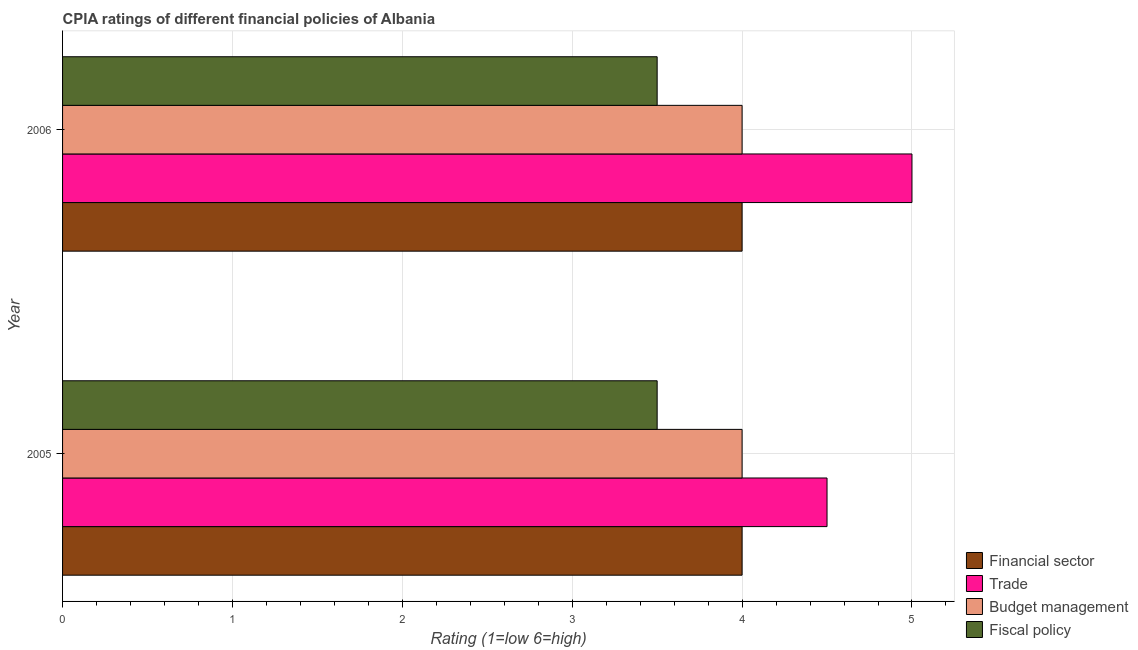How many bars are there on the 2nd tick from the top?
Your response must be concise. 4. Across all years, what is the maximum cpia rating of financial sector?
Ensure brevity in your answer.  4. Across all years, what is the minimum cpia rating of financial sector?
Offer a terse response. 4. What is the total cpia rating of financial sector in the graph?
Provide a short and direct response. 8. What is the average cpia rating of trade per year?
Your response must be concise. 4.75. In how many years, is the cpia rating of fiscal policy greater than 4 ?
Give a very brief answer. 0. What is the ratio of the cpia rating of financial sector in 2005 to that in 2006?
Give a very brief answer. 1. Is the cpia rating of fiscal policy in 2005 less than that in 2006?
Your response must be concise. No. In how many years, is the cpia rating of budget management greater than the average cpia rating of budget management taken over all years?
Make the answer very short. 0. What does the 3rd bar from the top in 2005 represents?
Provide a short and direct response. Trade. What does the 2nd bar from the bottom in 2006 represents?
Provide a succinct answer. Trade. Is it the case that in every year, the sum of the cpia rating of financial sector and cpia rating of trade is greater than the cpia rating of budget management?
Provide a short and direct response. Yes. How many bars are there?
Give a very brief answer. 8. Are the values on the major ticks of X-axis written in scientific E-notation?
Offer a terse response. No. How many legend labels are there?
Your response must be concise. 4. What is the title of the graph?
Ensure brevity in your answer.  CPIA ratings of different financial policies of Albania. Does "Permanent crop land" appear as one of the legend labels in the graph?
Ensure brevity in your answer.  No. What is the label or title of the Y-axis?
Give a very brief answer. Year. What is the Rating (1=low 6=high) of Budget management in 2005?
Offer a very short reply. 4. What is the Rating (1=low 6=high) of Fiscal policy in 2005?
Keep it short and to the point. 3.5. What is the Rating (1=low 6=high) of Budget management in 2006?
Give a very brief answer. 4. What is the Rating (1=low 6=high) of Fiscal policy in 2006?
Provide a short and direct response. 3.5. Across all years, what is the minimum Rating (1=low 6=high) of Financial sector?
Provide a succinct answer. 4. Across all years, what is the minimum Rating (1=low 6=high) of Fiscal policy?
Provide a succinct answer. 3.5. What is the total Rating (1=low 6=high) of Financial sector in the graph?
Ensure brevity in your answer.  8. What is the total Rating (1=low 6=high) in Trade in the graph?
Give a very brief answer. 9.5. What is the total Rating (1=low 6=high) of Budget management in the graph?
Your response must be concise. 8. What is the difference between the Rating (1=low 6=high) in Budget management in 2005 and that in 2006?
Ensure brevity in your answer.  0. What is the difference between the Rating (1=low 6=high) of Financial sector in 2005 and the Rating (1=low 6=high) of Trade in 2006?
Your answer should be compact. -1. What is the difference between the Rating (1=low 6=high) of Financial sector in 2005 and the Rating (1=low 6=high) of Budget management in 2006?
Give a very brief answer. 0. What is the difference between the Rating (1=low 6=high) of Trade in 2005 and the Rating (1=low 6=high) of Budget management in 2006?
Ensure brevity in your answer.  0.5. What is the difference between the Rating (1=low 6=high) in Budget management in 2005 and the Rating (1=low 6=high) in Fiscal policy in 2006?
Your response must be concise. 0.5. What is the average Rating (1=low 6=high) of Trade per year?
Your answer should be very brief. 4.75. What is the average Rating (1=low 6=high) in Budget management per year?
Ensure brevity in your answer.  4. In the year 2005, what is the difference between the Rating (1=low 6=high) in Financial sector and Rating (1=low 6=high) in Trade?
Your answer should be very brief. -0.5. In the year 2005, what is the difference between the Rating (1=low 6=high) in Financial sector and Rating (1=low 6=high) in Budget management?
Give a very brief answer. 0. In the year 2005, what is the difference between the Rating (1=low 6=high) in Financial sector and Rating (1=low 6=high) in Fiscal policy?
Your answer should be compact. 0.5. In the year 2005, what is the difference between the Rating (1=low 6=high) in Trade and Rating (1=low 6=high) in Budget management?
Give a very brief answer. 0.5. In the year 2006, what is the difference between the Rating (1=low 6=high) in Financial sector and Rating (1=low 6=high) in Fiscal policy?
Ensure brevity in your answer.  0.5. In the year 2006, what is the difference between the Rating (1=low 6=high) in Trade and Rating (1=low 6=high) in Budget management?
Make the answer very short. 1. In the year 2006, what is the difference between the Rating (1=low 6=high) in Budget management and Rating (1=low 6=high) in Fiscal policy?
Offer a terse response. 0.5. What is the ratio of the Rating (1=low 6=high) of Trade in 2005 to that in 2006?
Give a very brief answer. 0.9. What is the ratio of the Rating (1=low 6=high) in Budget management in 2005 to that in 2006?
Make the answer very short. 1. What is the ratio of the Rating (1=low 6=high) of Fiscal policy in 2005 to that in 2006?
Ensure brevity in your answer.  1. What is the difference between the highest and the second highest Rating (1=low 6=high) of Financial sector?
Your answer should be very brief. 0. What is the difference between the highest and the second highest Rating (1=low 6=high) in Trade?
Your answer should be very brief. 0.5. What is the difference between the highest and the second highest Rating (1=low 6=high) in Budget management?
Offer a very short reply. 0. What is the difference between the highest and the lowest Rating (1=low 6=high) of Trade?
Ensure brevity in your answer.  0.5. What is the difference between the highest and the lowest Rating (1=low 6=high) of Budget management?
Offer a terse response. 0. What is the difference between the highest and the lowest Rating (1=low 6=high) of Fiscal policy?
Your answer should be very brief. 0. 